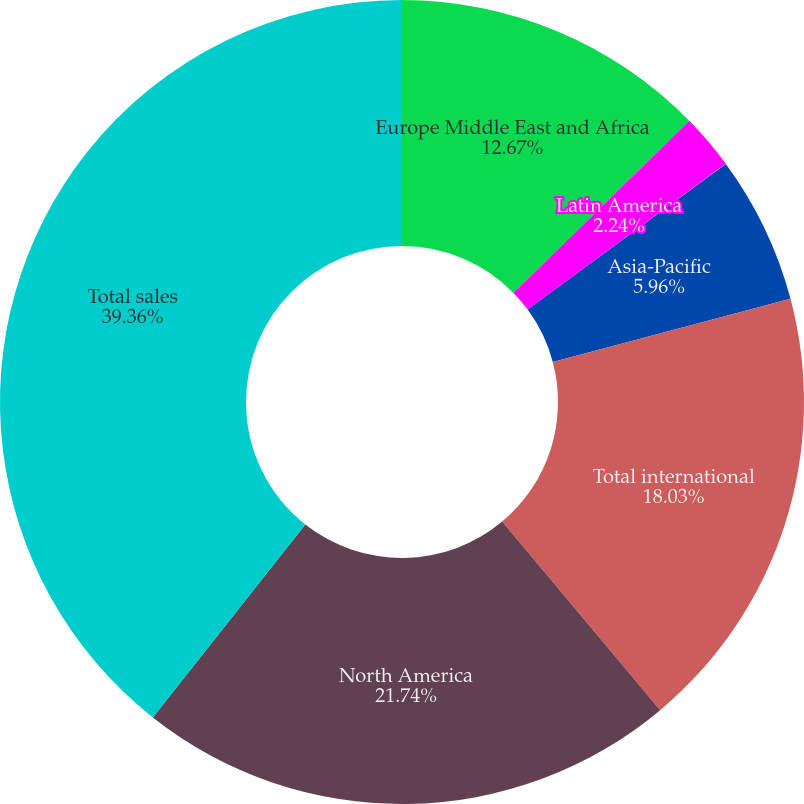<chart> <loc_0><loc_0><loc_500><loc_500><pie_chart><fcel>Europe Middle East and Africa<fcel>Latin America<fcel>Asia-Pacific<fcel>Total international<fcel>North America<fcel>Total sales<nl><fcel>12.67%<fcel>2.24%<fcel>5.96%<fcel>18.03%<fcel>21.74%<fcel>39.36%<nl></chart> 